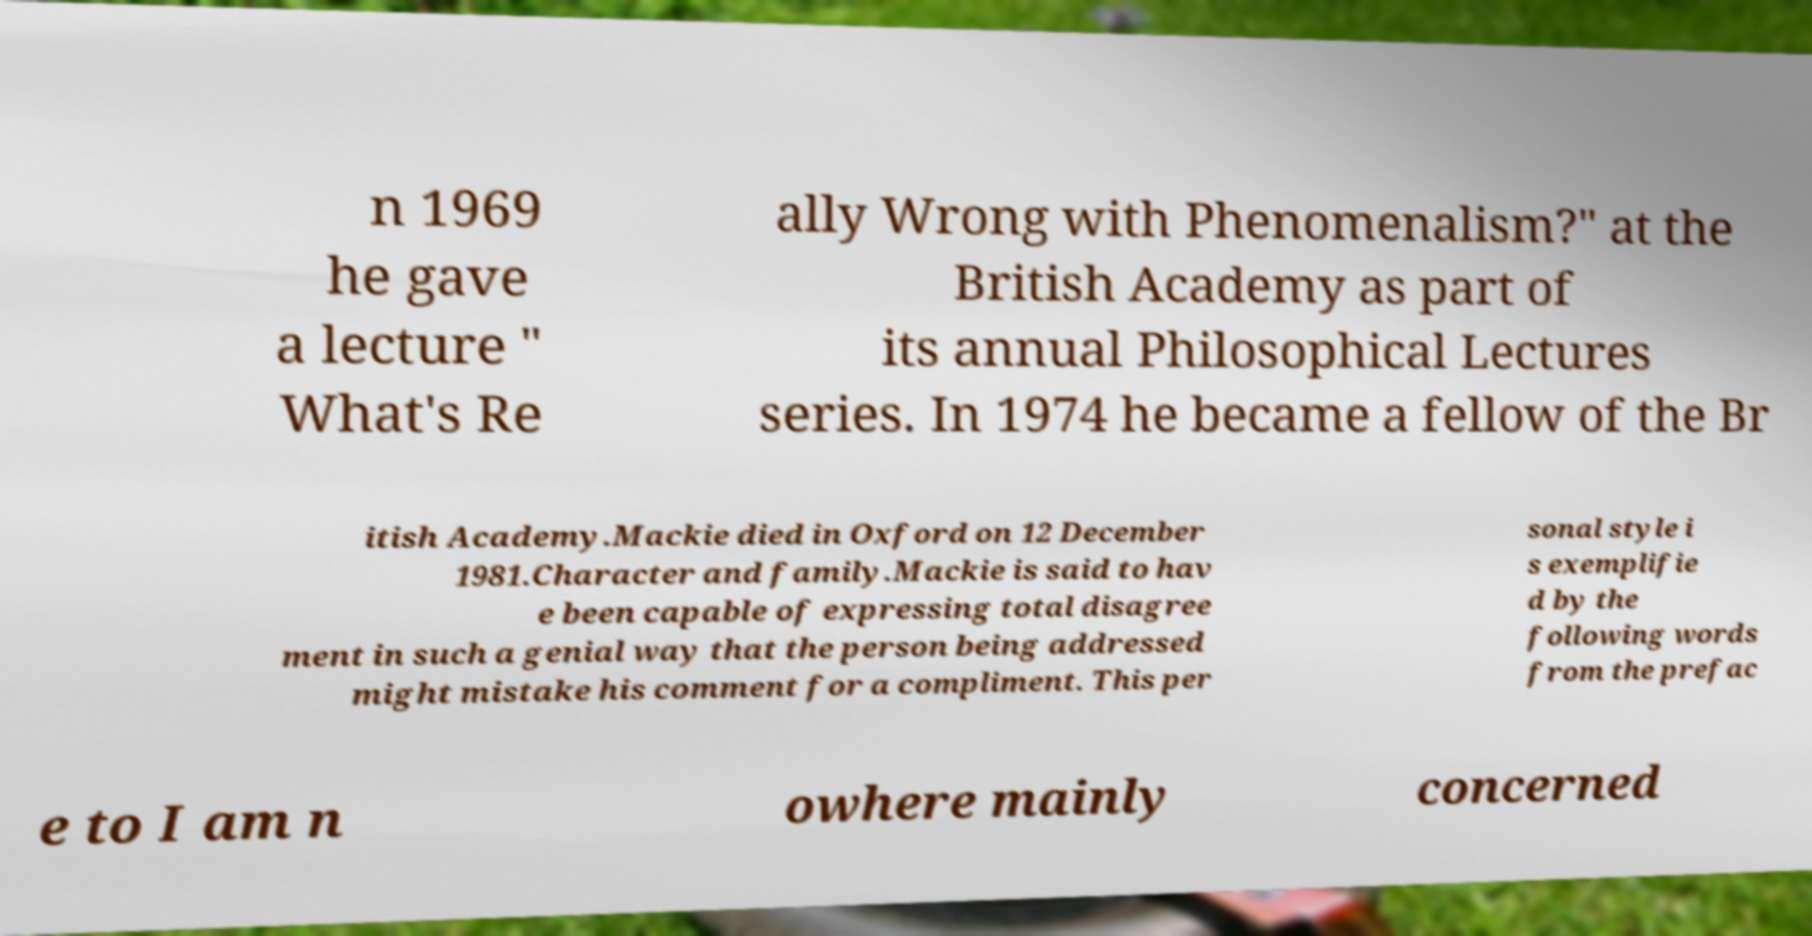There's text embedded in this image that I need extracted. Can you transcribe it verbatim? n 1969 he gave a lecture " What's Re ally Wrong with Phenomenalism?" at the British Academy as part of its annual Philosophical Lectures series. In 1974 he became a fellow of the Br itish Academy.Mackie died in Oxford on 12 December 1981.Character and family.Mackie is said to hav e been capable of expressing total disagree ment in such a genial way that the person being addressed might mistake his comment for a compliment. This per sonal style i s exemplifie d by the following words from the prefac e to I am n owhere mainly concerned 